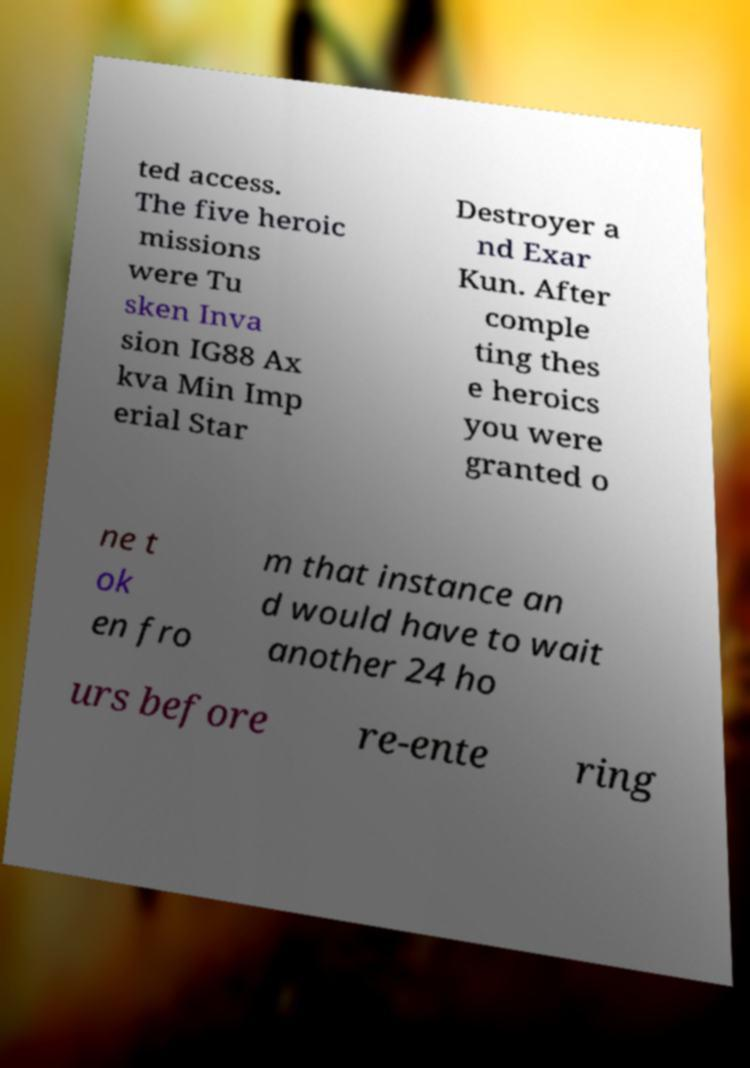Please read and relay the text visible in this image. What does it say? ted access. The five heroic missions were Tu sken Inva sion IG88 Ax kva Min Imp erial Star Destroyer a nd Exar Kun. After comple ting thes e heroics you were granted o ne t ok en fro m that instance an d would have to wait another 24 ho urs before re-ente ring 